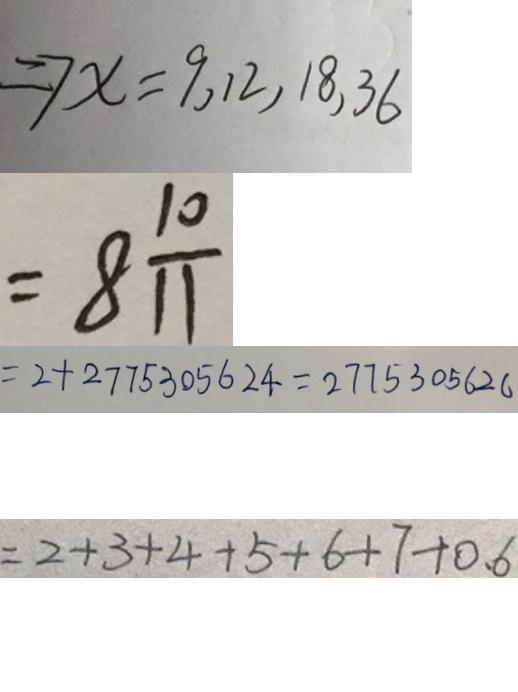<formula> <loc_0><loc_0><loc_500><loc_500>\Rightarrow x = 9 , 1 2 , 1 8 , 3 6 
 = 8 \frac { 1 0 } { 1 1 } 
 = 2 + 2 7 7 5 3 0 5 6 2 4 = 2 7 7 5 3 0 5 6 2 0 
 = 2 + 3 + 4 + 5 + 6 + 7 + 0 . 6</formula> 